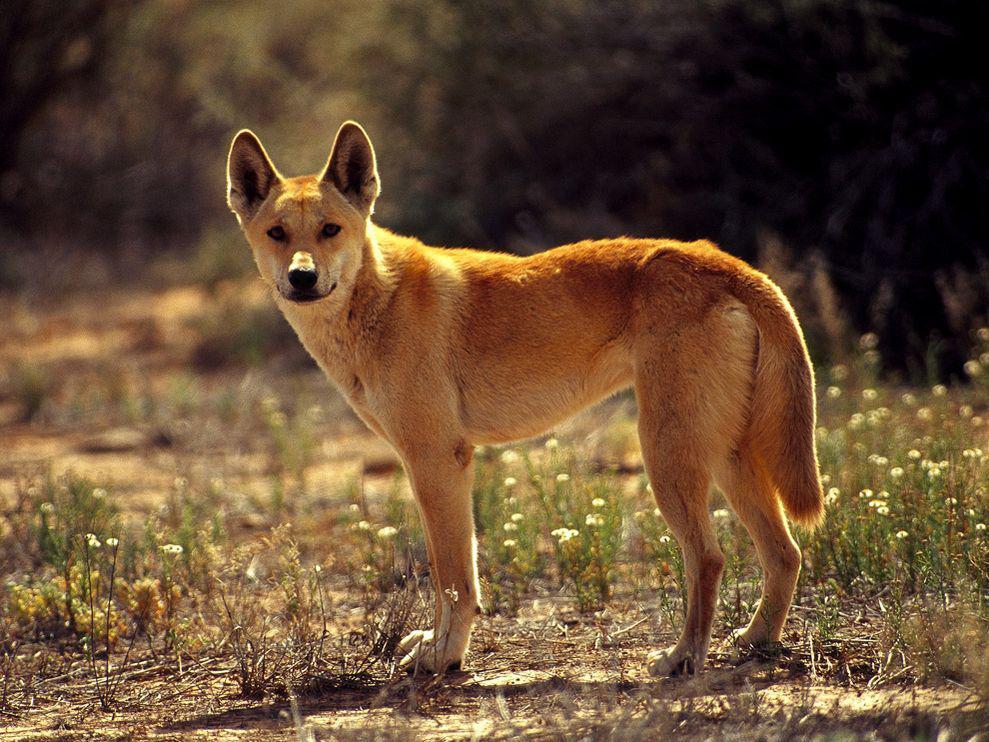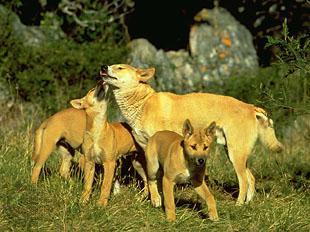The first image is the image on the left, the second image is the image on the right. Given the left and right images, does the statement "there are two animals" hold true? Answer yes or no. No. 